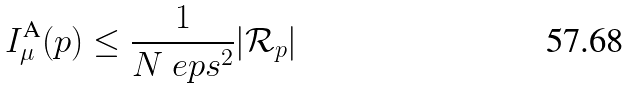<formula> <loc_0><loc_0><loc_500><loc_500>I ^ { \text {A} } _ { \mu } ( p ) \leq \frac { 1 } { N \ e p s ^ { 2 } } | \mathcal { R } _ { p } |</formula> 